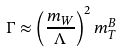Convert formula to latex. <formula><loc_0><loc_0><loc_500><loc_500>\Gamma \approx \left ( \frac { m _ { W } } { \Lambda } \right ) ^ { 2 } m _ { T } ^ { B }</formula> 